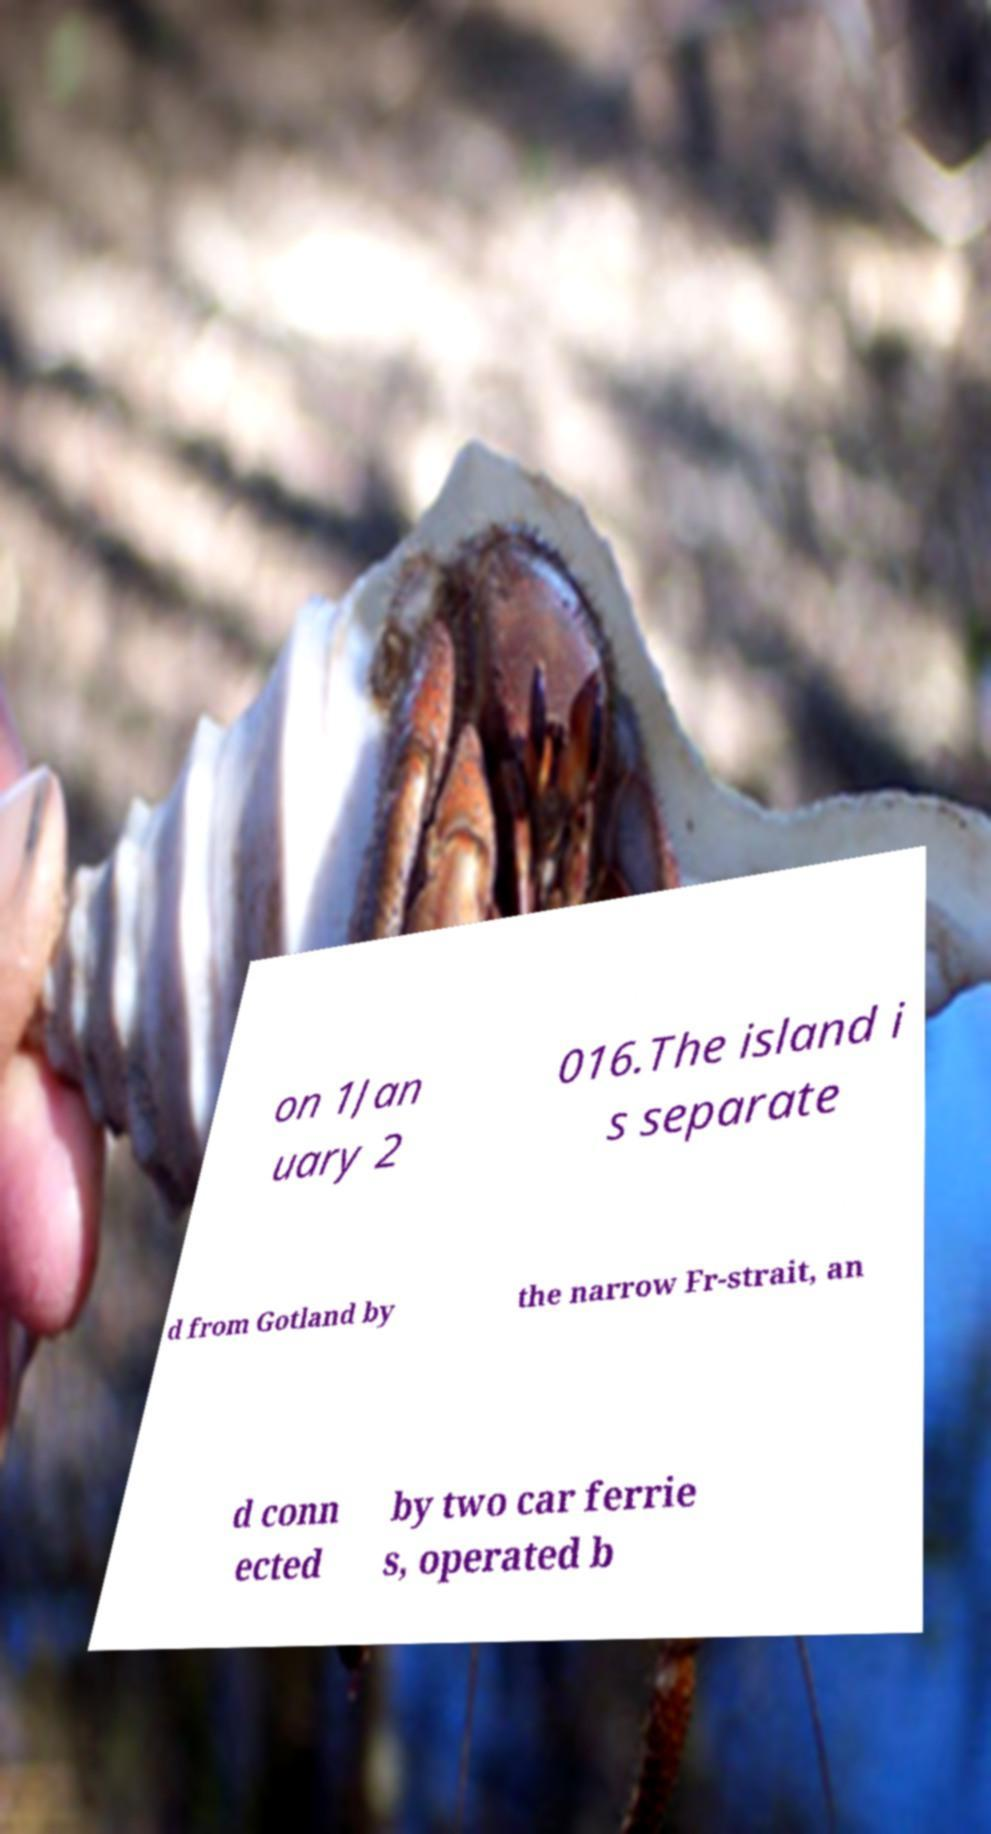There's text embedded in this image that I need extracted. Can you transcribe it verbatim? on 1Jan uary 2 016.The island i s separate d from Gotland by the narrow Fr-strait, an d conn ected by two car ferrie s, operated b 